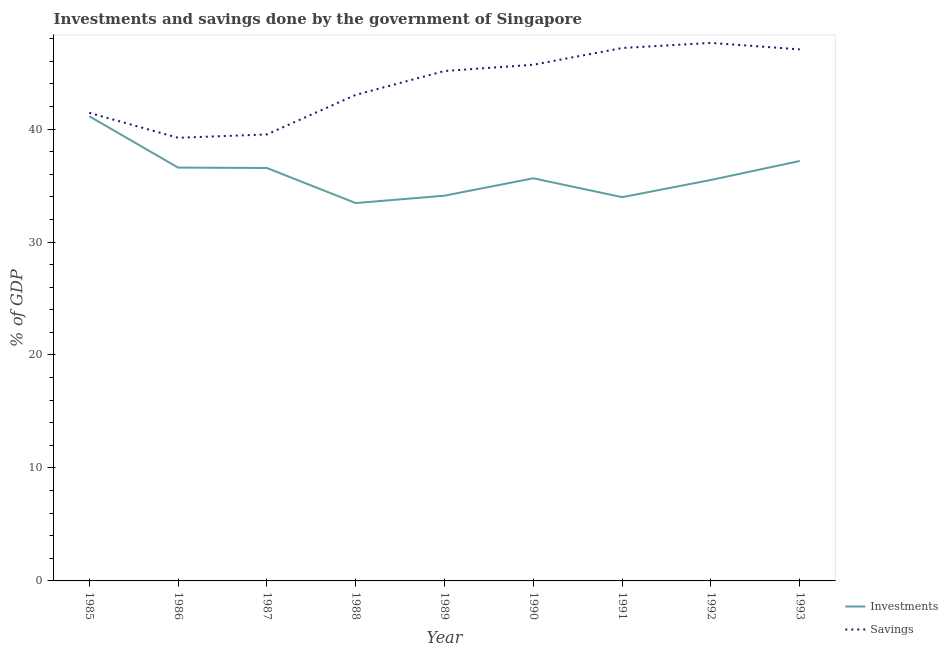How many different coloured lines are there?
Provide a succinct answer. 2. Does the line corresponding to savings of government intersect with the line corresponding to investments of government?
Your response must be concise. No. Is the number of lines equal to the number of legend labels?
Offer a terse response. Yes. What is the investments of government in 1985?
Your response must be concise. 41.13. Across all years, what is the maximum investments of government?
Make the answer very short. 41.13. Across all years, what is the minimum savings of government?
Make the answer very short. 39.23. In which year was the savings of government maximum?
Make the answer very short. 1992. In which year was the savings of government minimum?
Offer a terse response. 1986. What is the total investments of government in the graph?
Your response must be concise. 324.09. What is the difference between the investments of government in 1987 and that in 1992?
Provide a short and direct response. 1.06. What is the difference between the investments of government in 1989 and the savings of government in 1990?
Your answer should be very brief. -11.59. What is the average savings of government per year?
Your response must be concise. 43.99. In the year 1992, what is the difference between the savings of government and investments of government?
Your answer should be very brief. 12.13. What is the ratio of the investments of government in 1986 to that in 1993?
Give a very brief answer. 0.98. Is the savings of government in 1991 less than that in 1992?
Give a very brief answer. Yes. Is the difference between the investments of government in 1986 and 1990 greater than the difference between the savings of government in 1986 and 1990?
Provide a succinct answer. Yes. What is the difference between the highest and the second highest savings of government?
Offer a very short reply. 0.46. What is the difference between the highest and the lowest investments of government?
Your answer should be very brief. 7.69. In how many years, is the investments of government greater than the average investments of government taken over all years?
Provide a short and direct response. 4. Is the sum of the investments of government in 1987 and 1989 greater than the maximum savings of government across all years?
Give a very brief answer. Yes. Does the investments of government monotonically increase over the years?
Give a very brief answer. No. Is the investments of government strictly less than the savings of government over the years?
Provide a short and direct response. Yes. How many years are there in the graph?
Provide a succinct answer. 9. What is the difference between two consecutive major ticks on the Y-axis?
Provide a short and direct response. 10. Are the values on the major ticks of Y-axis written in scientific E-notation?
Provide a succinct answer. No. Does the graph contain any zero values?
Give a very brief answer. No. Does the graph contain grids?
Offer a terse response. No. What is the title of the graph?
Provide a succinct answer. Investments and savings done by the government of Singapore. What is the label or title of the X-axis?
Ensure brevity in your answer.  Year. What is the label or title of the Y-axis?
Your answer should be very brief. % of GDP. What is the % of GDP in Investments in 1985?
Your answer should be very brief. 41.13. What is the % of GDP in Savings in 1985?
Offer a very short reply. 41.43. What is the % of GDP of Investments in 1986?
Provide a short and direct response. 36.59. What is the % of GDP of Savings in 1986?
Your response must be concise. 39.23. What is the % of GDP of Investments in 1987?
Offer a terse response. 36.55. What is the % of GDP in Savings in 1987?
Your answer should be very brief. 39.52. What is the % of GDP of Investments in 1988?
Keep it short and to the point. 33.45. What is the % of GDP of Savings in 1988?
Your answer should be very brief. 43.02. What is the % of GDP of Investments in 1989?
Your answer should be compact. 34.1. What is the % of GDP in Savings in 1989?
Your response must be concise. 45.14. What is the % of GDP of Investments in 1990?
Provide a short and direct response. 35.64. What is the % of GDP in Savings in 1990?
Keep it short and to the point. 45.69. What is the % of GDP in Investments in 1991?
Provide a short and direct response. 33.97. What is the % of GDP in Savings in 1991?
Ensure brevity in your answer.  47.17. What is the % of GDP of Investments in 1992?
Provide a short and direct response. 35.49. What is the % of GDP in Savings in 1992?
Ensure brevity in your answer.  47.63. What is the % of GDP of Investments in 1993?
Provide a short and direct response. 37.17. What is the % of GDP of Savings in 1993?
Your answer should be compact. 47.05. Across all years, what is the maximum % of GDP of Investments?
Make the answer very short. 41.13. Across all years, what is the maximum % of GDP of Savings?
Offer a terse response. 47.63. Across all years, what is the minimum % of GDP of Investments?
Your response must be concise. 33.45. Across all years, what is the minimum % of GDP in Savings?
Offer a terse response. 39.23. What is the total % of GDP in Investments in the graph?
Keep it short and to the point. 324.09. What is the total % of GDP of Savings in the graph?
Offer a very short reply. 395.88. What is the difference between the % of GDP in Investments in 1985 and that in 1986?
Offer a terse response. 4.55. What is the difference between the % of GDP of Savings in 1985 and that in 1986?
Give a very brief answer. 2.21. What is the difference between the % of GDP in Investments in 1985 and that in 1987?
Provide a short and direct response. 4.58. What is the difference between the % of GDP of Savings in 1985 and that in 1987?
Make the answer very short. 1.91. What is the difference between the % of GDP of Investments in 1985 and that in 1988?
Provide a short and direct response. 7.69. What is the difference between the % of GDP of Savings in 1985 and that in 1988?
Give a very brief answer. -1.59. What is the difference between the % of GDP in Investments in 1985 and that in 1989?
Give a very brief answer. 7.03. What is the difference between the % of GDP of Savings in 1985 and that in 1989?
Give a very brief answer. -3.7. What is the difference between the % of GDP in Investments in 1985 and that in 1990?
Ensure brevity in your answer.  5.49. What is the difference between the % of GDP of Savings in 1985 and that in 1990?
Make the answer very short. -4.26. What is the difference between the % of GDP in Investments in 1985 and that in 1991?
Your answer should be compact. 7.16. What is the difference between the % of GDP in Savings in 1985 and that in 1991?
Provide a succinct answer. -5.74. What is the difference between the % of GDP of Investments in 1985 and that in 1992?
Ensure brevity in your answer.  5.64. What is the difference between the % of GDP of Savings in 1985 and that in 1992?
Your answer should be compact. -6.19. What is the difference between the % of GDP of Investments in 1985 and that in 1993?
Provide a short and direct response. 3.96. What is the difference between the % of GDP in Savings in 1985 and that in 1993?
Ensure brevity in your answer.  -5.62. What is the difference between the % of GDP in Investments in 1986 and that in 1987?
Your response must be concise. 0.04. What is the difference between the % of GDP of Savings in 1986 and that in 1987?
Offer a very short reply. -0.3. What is the difference between the % of GDP in Investments in 1986 and that in 1988?
Your answer should be compact. 3.14. What is the difference between the % of GDP in Savings in 1986 and that in 1988?
Ensure brevity in your answer.  -3.8. What is the difference between the % of GDP of Investments in 1986 and that in 1989?
Keep it short and to the point. 2.49. What is the difference between the % of GDP in Savings in 1986 and that in 1989?
Your answer should be very brief. -5.91. What is the difference between the % of GDP in Investments in 1986 and that in 1990?
Your answer should be very brief. 0.95. What is the difference between the % of GDP in Savings in 1986 and that in 1990?
Provide a short and direct response. -6.47. What is the difference between the % of GDP of Investments in 1986 and that in 1991?
Offer a terse response. 2.62. What is the difference between the % of GDP in Savings in 1986 and that in 1991?
Offer a very short reply. -7.95. What is the difference between the % of GDP in Investments in 1986 and that in 1992?
Give a very brief answer. 1.09. What is the difference between the % of GDP of Savings in 1986 and that in 1992?
Provide a short and direct response. -8.4. What is the difference between the % of GDP in Investments in 1986 and that in 1993?
Keep it short and to the point. -0.58. What is the difference between the % of GDP in Savings in 1986 and that in 1993?
Ensure brevity in your answer.  -7.82. What is the difference between the % of GDP in Investments in 1987 and that in 1988?
Your answer should be compact. 3.1. What is the difference between the % of GDP in Savings in 1987 and that in 1988?
Your response must be concise. -3.5. What is the difference between the % of GDP of Investments in 1987 and that in 1989?
Your response must be concise. 2.45. What is the difference between the % of GDP in Savings in 1987 and that in 1989?
Offer a very short reply. -5.61. What is the difference between the % of GDP in Investments in 1987 and that in 1990?
Keep it short and to the point. 0.91. What is the difference between the % of GDP in Savings in 1987 and that in 1990?
Keep it short and to the point. -6.17. What is the difference between the % of GDP of Investments in 1987 and that in 1991?
Your answer should be compact. 2.58. What is the difference between the % of GDP in Savings in 1987 and that in 1991?
Give a very brief answer. -7.65. What is the difference between the % of GDP in Investments in 1987 and that in 1992?
Give a very brief answer. 1.06. What is the difference between the % of GDP of Savings in 1987 and that in 1992?
Ensure brevity in your answer.  -8.1. What is the difference between the % of GDP in Investments in 1987 and that in 1993?
Your answer should be compact. -0.62. What is the difference between the % of GDP in Savings in 1987 and that in 1993?
Offer a very short reply. -7.53. What is the difference between the % of GDP in Investments in 1988 and that in 1989?
Ensure brevity in your answer.  -0.65. What is the difference between the % of GDP in Savings in 1988 and that in 1989?
Provide a short and direct response. -2.11. What is the difference between the % of GDP of Investments in 1988 and that in 1990?
Your answer should be compact. -2.19. What is the difference between the % of GDP in Savings in 1988 and that in 1990?
Keep it short and to the point. -2.67. What is the difference between the % of GDP in Investments in 1988 and that in 1991?
Your answer should be compact. -0.52. What is the difference between the % of GDP of Savings in 1988 and that in 1991?
Offer a very short reply. -4.15. What is the difference between the % of GDP in Investments in 1988 and that in 1992?
Your answer should be compact. -2.04. What is the difference between the % of GDP of Savings in 1988 and that in 1992?
Give a very brief answer. -4.6. What is the difference between the % of GDP of Investments in 1988 and that in 1993?
Make the answer very short. -3.72. What is the difference between the % of GDP of Savings in 1988 and that in 1993?
Offer a terse response. -4.03. What is the difference between the % of GDP in Investments in 1989 and that in 1990?
Provide a short and direct response. -1.54. What is the difference between the % of GDP in Savings in 1989 and that in 1990?
Your response must be concise. -0.56. What is the difference between the % of GDP of Investments in 1989 and that in 1991?
Offer a terse response. 0.13. What is the difference between the % of GDP in Savings in 1989 and that in 1991?
Offer a very short reply. -2.04. What is the difference between the % of GDP of Investments in 1989 and that in 1992?
Keep it short and to the point. -1.39. What is the difference between the % of GDP in Savings in 1989 and that in 1992?
Provide a succinct answer. -2.49. What is the difference between the % of GDP in Investments in 1989 and that in 1993?
Provide a succinct answer. -3.07. What is the difference between the % of GDP of Savings in 1989 and that in 1993?
Offer a terse response. -1.91. What is the difference between the % of GDP of Investments in 1990 and that in 1991?
Offer a terse response. 1.67. What is the difference between the % of GDP of Savings in 1990 and that in 1991?
Keep it short and to the point. -1.48. What is the difference between the % of GDP of Investments in 1990 and that in 1992?
Offer a very short reply. 0.15. What is the difference between the % of GDP in Savings in 1990 and that in 1992?
Give a very brief answer. -1.93. What is the difference between the % of GDP of Investments in 1990 and that in 1993?
Ensure brevity in your answer.  -1.53. What is the difference between the % of GDP in Savings in 1990 and that in 1993?
Your answer should be very brief. -1.36. What is the difference between the % of GDP of Investments in 1991 and that in 1992?
Provide a short and direct response. -1.52. What is the difference between the % of GDP of Savings in 1991 and that in 1992?
Your response must be concise. -0.46. What is the difference between the % of GDP of Investments in 1991 and that in 1993?
Ensure brevity in your answer.  -3.2. What is the difference between the % of GDP in Savings in 1991 and that in 1993?
Make the answer very short. 0.12. What is the difference between the % of GDP of Investments in 1992 and that in 1993?
Provide a succinct answer. -1.68. What is the difference between the % of GDP in Savings in 1992 and that in 1993?
Keep it short and to the point. 0.58. What is the difference between the % of GDP in Investments in 1985 and the % of GDP in Savings in 1986?
Offer a terse response. 1.91. What is the difference between the % of GDP of Investments in 1985 and the % of GDP of Savings in 1987?
Your answer should be very brief. 1.61. What is the difference between the % of GDP of Investments in 1985 and the % of GDP of Savings in 1988?
Give a very brief answer. -1.89. What is the difference between the % of GDP in Investments in 1985 and the % of GDP in Savings in 1989?
Make the answer very short. -4. What is the difference between the % of GDP of Investments in 1985 and the % of GDP of Savings in 1990?
Provide a short and direct response. -4.56. What is the difference between the % of GDP in Investments in 1985 and the % of GDP in Savings in 1991?
Give a very brief answer. -6.04. What is the difference between the % of GDP of Investments in 1985 and the % of GDP of Savings in 1992?
Your answer should be very brief. -6.49. What is the difference between the % of GDP of Investments in 1985 and the % of GDP of Savings in 1993?
Give a very brief answer. -5.92. What is the difference between the % of GDP of Investments in 1986 and the % of GDP of Savings in 1987?
Your answer should be compact. -2.94. What is the difference between the % of GDP of Investments in 1986 and the % of GDP of Savings in 1988?
Give a very brief answer. -6.43. What is the difference between the % of GDP of Investments in 1986 and the % of GDP of Savings in 1989?
Your answer should be compact. -8.55. What is the difference between the % of GDP in Investments in 1986 and the % of GDP in Savings in 1990?
Provide a succinct answer. -9.1. What is the difference between the % of GDP of Investments in 1986 and the % of GDP of Savings in 1991?
Your answer should be compact. -10.58. What is the difference between the % of GDP of Investments in 1986 and the % of GDP of Savings in 1992?
Your answer should be compact. -11.04. What is the difference between the % of GDP of Investments in 1986 and the % of GDP of Savings in 1993?
Offer a terse response. -10.46. What is the difference between the % of GDP in Investments in 1987 and the % of GDP in Savings in 1988?
Offer a very short reply. -6.47. What is the difference between the % of GDP of Investments in 1987 and the % of GDP of Savings in 1989?
Keep it short and to the point. -8.58. What is the difference between the % of GDP of Investments in 1987 and the % of GDP of Savings in 1990?
Offer a terse response. -9.14. What is the difference between the % of GDP in Investments in 1987 and the % of GDP in Savings in 1991?
Provide a succinct answer. -10.62. What is the difference between the % of GDP in Investments in 1987 and the % of GDP in Savings in 1992?
Ensure brevity in your answer.  -11.07. What is the difference between the % of GDP in Investments in 1987 and the % of GDP in Savings in 1993?
Your answer should be very brief. -10.5. What is the difference between the % of GDP in Investments in 1988 and the % of GDP in Savings in 1989?
Offer a terse response. -11.69. What is the difference between the % of GDP in Investments in 1988 and the % of GDP in Savings in 1990?
Offer a terse response. -12.24. What is the difference between the % of GDP of Investments in 1988 and the % of GDP of Savings in 1991?
Your response must be concise. -13.72. What is the difference between the % of GDP in Investments in 1988 and the % of GDP in Savings in 1992?
Provide a succinct answer. -14.18. What is the difference between the % of GDP of Investments in 1988 and the % of GDP of Savings in 1993?
Make the answer very short. -13.6. What is the difference between the % of GDP of Investments in 1989 and the % of GDP of Savings in 1990?
Give a very brief answer. -11.59. What is the difference between the % of GDP in Investments in 1989 and the % of GDP in Savings in 1991?
Provide a succinct answer. -13.07. What is the difference between the % of GDP of Investments in 1989 and the % of GDP of Savings in 1992?
Provide a short and direct response. -13.52. What is the difference between the % of GDP of Investments in 1989 and the % of GDP of Savings in 1993?
Provide a short and direct response. -12.95. What is the difference between the % of GDP in Investments in 1990 and the % of GDP in Savings in 1991?
Make the answer very short. -11.53. What is the difference between the % of GDP in Investments in 1990 and the % of GDP in Savings in 1992?
Your answer should be very brief. -11.99. What is the difference between the % of GDP in Investments in 1990 and the % of GDP in Savings in 1993?
Make the answer very short. -11.41. What is the difference between the % of GDP of Investments in 1991 and the % of GDP of Savings in 1992?
Your response must be concise. -13.66. What is the difference between the % of GDP in Investments in 1991 and the % of GDP in Savings in 1993?
Your response must be concise. -13.08. What is the difference between the % of GDP of Investments in 1992 and the % of GDP of Savings in 1993?
Offer a very short reply. -11.56. What is the average % of GDP of Investments per year?
Your answer should be compact. 36.01. What is the average % of GDP in Savings per year?
Your answer should be compact. 43.99. In the year 1985, what is the difference between the % of GDP of Investments and % of GDP of Savings?
Provide a succinct answer. -0.3. In the year 1986, what is the difference between the % of GDP in Investments and % of GDP in Savings?
Ensure brevity in your answer.  -2.64. In the year 1987, what is the difference between the % of GDP of Investments and % of GDP of Savings?
Offer a terse response. -2.97. In the year 1988, what is the difference between the % of GDP of Investments and % of GDP of Savings?
Keep it short and to the point. -9.57. In the year 1989, what is the difference between the % of GDP in Investments and % of GDP in Savings?
Offer a terse response. -11.03. In the year 1990, what is the difference between the % of GDP in Investments and % of GDP in Savings?
Your answer should be very brief. -10.05. In the year 1991, what is the difference between the % of GDP of Investments and % of GDP of Savings?
Your response must be concise. -13.2. In the year 1992, what is the difference between the % of GDP of Investments and % of GDP of Savings?
Give a very brief answer. -12.13. In the year 1993, what is the difference between the % of GDP of Investments and % of GDP of Savings?
Offer a very short reply. -9.88. What is the ratio of the % of GDP of Investments in 1985 to that in 1986?
Your response must be concise. 1.12. What is the ratio of the % of GDP in Savings in 1985 to that in 1986?
Give a very brief answer. 1.06. What is the ratio of the % of GDP in Investments in 1985 to that in 1987?
Offer a terse response. 1.13. What is the ratio of the % of GDP in Savings in 1985 to that in 1987?
Keep it short and to the point. 1.05. What is the ratio of the % of GDP in Investments in 1985 to that in 1988?
Provide a succinct answer. 1.23. What is the ratio of the % of GDP in Savings in 1985 to that in 1988?
Ensure brevity in your answer.  0.96. What is the ratio of the % of GDP of Investments in 1985 to that in 1989?
Your answer should be very brief. 1.21. What is the ratio of the % of GDP in Savings in 1985 to that in 1989?
Offer a terse response. 0.92. What is the ratio of the % of GDP in Investments in 1985 to that in 1990?
Offer a very short reply. 1.15. What is the ratio of the % of GDP of Savings in 1985 to that in 1990?
Your answer should be very brief. 0.91. What is the ratio of the % of GDP of Investments in 1985 to that in 1991?
Offer a terse response. 1.21. What is the ratio of the % of GDP of Savings in 1985 to that in 1991?
Give a very brief answer. 0.88. What is the ratio of the % of GDP in Investments in 1985 to that in 1992?
Your answer should be very brief. 1.16. What is the ratio of the % of GDP in Savings in 1985 to that in 1992?
Offer a very short reply. 0.87. What is the ratio of the % of GDP in Investments in 1985 to that in 1993?
Give a very brief answer. 1.11. What is the ratio of the % of GDP of Savings in 1985 to that in 1993?
Provide a short and direct response. 0.88. What is the ratio of the % of GDP in Investments in 1986 to that in 1987?
Give a very brief answer. 1. What is the ratio of the % of GDP in Investments in 1986 to that in 1988?
Keep it short and to the point. 1.09. What is the ratio of the % of GDP of Savings in 1986 to that in 1988?
Ensure brevity in your answer.  0.91. What is the ratio of the % of GDP of Investments in 1986 to that in 1989?
Ensure brevity in your answer.  1.07. What is the ratio of the % of GDP in Savings in 1986 to that in 1989?
Your answer should be compact. 0.87. What is the ratio of the % of GDP in Investments in 1986 to that in 1990?
Offer a very short reply. 1.03. What is the ratio of the % of GDP in Savings in 1986 to that in 1990?
Your answer should be very brief. 0.86. What is the ratio of the % of GDP of Investments in 1986 to that in 1991?
Offer a very short reply. 1.08. What is the ratio of the % of GDP of Savings in 1986 to that in 1991?
Offer a very short reply. 0.83. What is the ratio of the % of GDP in Investments in 1986 to that in 1992?
Provide a short and direct response. 1.03. What is the ratio of the % of GDP of Savings in 1986 to that in 1992?
Ensure brevity in your answer.  0.82. What is the ratio of the % of GDP of Investments in 1986 to that in 1993?
Provide a short and direct response. 0.98. What is the ratio of the % of GDP in Savings in 1986 to that in 1993?
Keep it short and to the point. 0.83. What is the ratio of the % of GDP in Investments in 1987 to that in 1988?
Ensure brevity in your answer.  1.09. What is the ratio of the % of GDP of Savings in 1987 to that in 1988?
Offer a terse response. 0.92. What is the ratio of the % of GDP in Investments in 1987 to that in 1989?
Your answer should be compact. 1.07. What is the ratio of the % of GDP in Savings in 1987 to that in 1989?
Offer a terse response. 0.88. What is the ratio of the % of GDP of Investments in 1987 to that in 1990?
Offer a terse response. 1.03. What is the ratio of the % of GDP of Savings in 1987 to that in 1990?
Provide a short and direct response. 0.86. What is the ratio of the % of GDP in Investments in 1987 to that in 1991?
Your response must be concise. 1.08. What is the ratio of the % of GDP in Savings in 1987 to that in 1991?
Offer a very short reply. 0.84. What is the ratio of the % of GDP of Investments in 1987 to that in 1992?
Provide a succinct answer. 1.03. What is the ratio of the % of GDP of Savings in 1987 to that in 1992?
Your answer should be very brief. 0.83. What is the ratio of the % of GDP in Investments in 1987 to that in 1993?
Offer a very short reply. 0.98. What is the ratio of the % of GDP in Savings in 1987 to that in 1993?
Provide a short and direct response. 0.84. What is the ratio of the % of GDP of Investments in 1988 to that in 1989?
Your response must be concise. 0.98. What is the ratio of the % of GDP of Savings in 1988 to that in 1989?
Provide a short and direct response. 0.95. What is the ratio of the % of GDP of Investments in 1988 to that in 1990?
Provide a short and direct response. 0.94. What is the ratio of the % of GDP in Savings in 1988 to that in 1990?
Offer a terse response. 0.94. What is the ratio of the % of GDP of Investments in 1988 to that in 1991?
Keep it short and to the point. 0.98. What is the ratio of the % of GDP in Savings in 1988 to that in 1991?
Give a very brief answer. 0.91. What is the ratio of the % of GDP in Investments in 1988 to that in 1992?
Your response must be concise. 0.94. What is the ratio of the % of GDP of Savings in 1988 to that in 1992?
Ensure brevity in your answer.  0.9. What is the ratio of the % of GDP of Investments in 1988 to that in 1993?
Offer a very short reply. 0.9. What is the ratio of the % of GDP in Savings in 1988 to that in 1993?
Offer a very short reply. 0.91. What is the ratio of the % of GDP in Investments in 1989 to that in 1990?
Provide a short and direct response. 0.96. What is the ratio of the % of GDP of Investments in 1989 to that in 1991?
Ensure brevity in your answer.  1. What is the ratio of the % of GDP of Savings in 1989 to that in 1991?
Provide a short and direct response. 0.96. What is the ratio of the % of GDP in Investments in 1989 to that in 1992?
Your answer should be compact. 0.96. What is the ratio of the % of GDP in Savings in 1989 to that in 1992?
Your response must be concise. 0.95. What is the ratio of the % of GDP in Investments in 1989 to that in 1993?
Offer a terse response. 0.92. What is the ratio of the % of GDP in Savings in 1989 to that in 1993?
Offer a terse response. 0.96. What is the ratio of the % of GDP in Investments in 1990 to that in 1991?
Ensure brevity in your answer.  1.05. What is the ratio of the % of GDP in Savings in 1990 to that in 1991?
Keep it short and to the point. 0.97. What is the ratio of the % of GDP of Savings in 1990 to that in 1992?
Provide a short and direct response. 0.96. What is the ratio of the % of GDP in Investments in 1990 to that in 1993?
Keep it short and to the point. 0.96. What is the ratio of the % of GDP in Savings in 1990 to that in 1993?
Offer a very short reply. 0.97. What is the ratio of the % of GDP of Investments in 1991 to that in 1992?
Offer a very short reply. 0.96. What is the ratio of the % of GDP of Savings in 1991 to that in 1992?
Offer a very short reply. 0.99. What is the ratio of the % of GDP in Investments in 1991 to that in 1993?
Offer a terse response. 0.91. What is the ratio of the % of GDP in Savings in 1991 to that in 1993?
Give a very brief answer. 1. What is the ratio of the % of GDP of Investments in 1992 to that in 1993?
Provide a succinct answer. 0.95. What is the ratio of the % of GDP of Savings in 1992 to that in 1993?
Give a very brief answer. 1.01. What is the difference between the highest and the second highest % of GDP in Investments?
Keep it short and to the point. 3.96. What is the difference between the highest and the second highest % of GDP of Savings?
Make the answer very short. 0.46. What is the difference between the highest and the lowest % of GDP of Investments?
Keep it short and to the point. 7.69. What is the difference between the highest and the lowest % of GDP in Savings?
Your answer should be very brief. 8.4. 